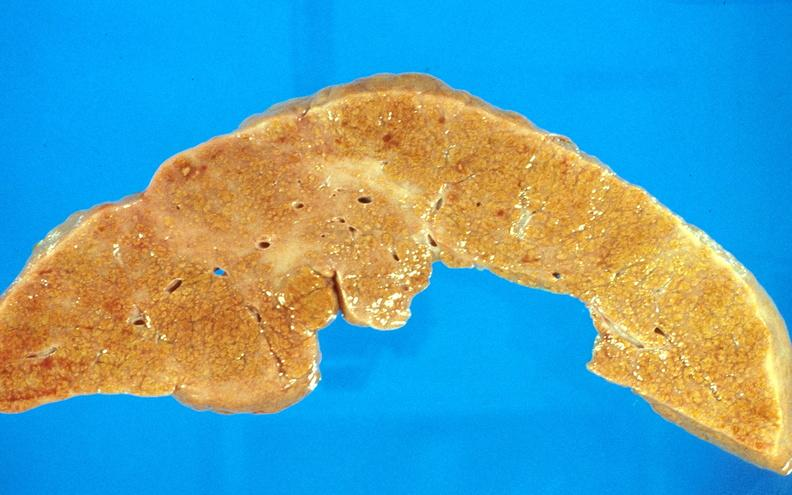does this image show cirrhosis?
Answer the question using a single word or phrase. Yes 